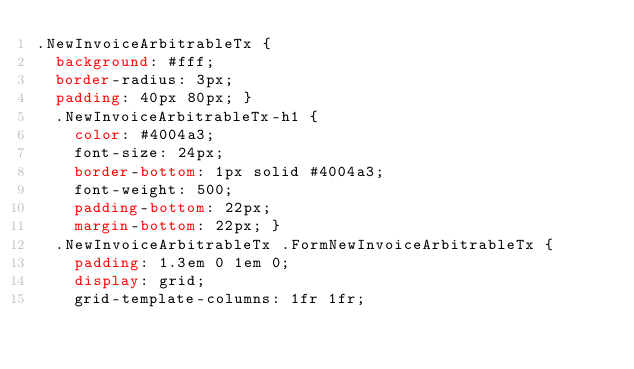<code> <loc_0><loc_0><loc_500><loc_500><_CSS_>.NewInvoiceArbitrableTx {
  background: #fff;
  border-radius: 3px;
  padding: 40px 80px; }
  .NewInvoiceArbitrableTx-h1 {
    color: #4004a3;
    font-size: 24px;
    border-bottom: 1px solid #4004a3;
    font-weight: 500;
    padding-bottom: 22px;
    margin-bottom: 22px; }
  .NewInvoiceArbitrableTx .FormNewInvoiceArbitrableTx {
    padding: 1.3em 0 1em 0;
    display: grid;
    grid-template-columns: 1fr 1fr;</code> 